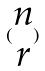<formula> <loc_0><loc_0><loc_500><loc_500>( \begin{matrix} n \\ r \end{matrix} )</formula> 